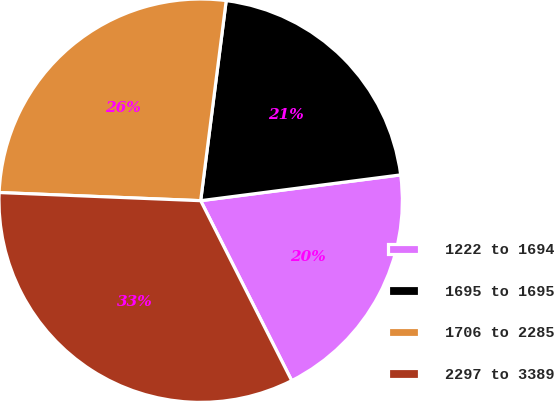Convert chart to OTSL. <chart><loc_0><loc_0><loc_500><loc_500><pie_chart><fcel>1222 to 1694<fcel>1695 to 1695<fcel>1706 to 2285<fcel>2297 to 3389<nl><fcel>19.59%<fcel>20.94%<fcel>26.38%<fcel>33.1%<nl></chart> 